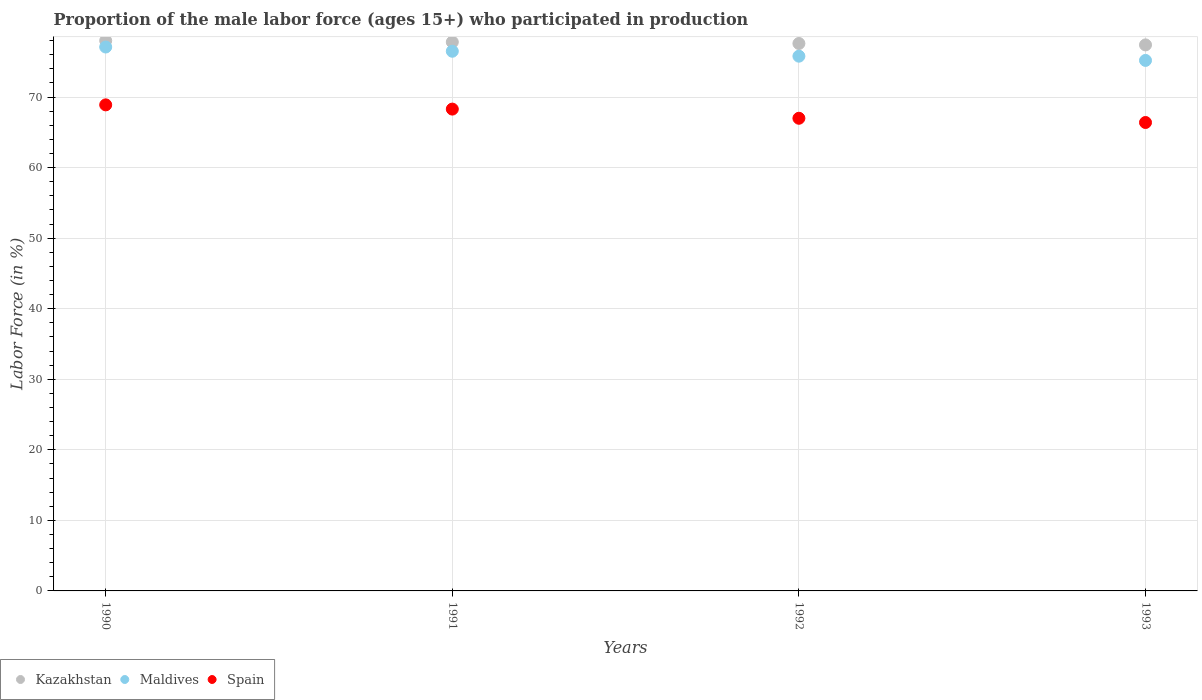Across all years, what is the minimum proportion of the male labor force who participated in production in Spain?
Offer a very short reply. 66.4. In which year was the proportion of the male labor force who participated in production in Spain maximum?
Keep it short and to the point. 1990. In which year was the proportion of the male labor force who participated in production in Spain minimum?
Ensure brevity in your answer.  1993. What is the total proportion of the male labor force who participated in production in Kazakhstan in the graph?
Make the answer very short. 310.8. What is the difference between the proportion of the male labor force who participated in production in Maldives in 1990 and that in 1992?
Keep it short and to the point. 1.3. What is the difference between the proportion of the male labor force who participated in production in Spain in 1991 and the proportion of the male labor force who participated in production in Maldives in 1990?
Offer a very short reply. -8.8. What is the average proportion of the male labor force who participated in production in Maldives per year?
Offer a terse response. 76.15. In the year 1992, what is the difference between the proportion of the male labor force who participated in production in Spain and proportion of the male labor force who participated in production in Kazakhstan?
Your response must be concise. -10.6. In how many years, is the proportion of the male labor force who participated in production in Spain greater than 38 %?
Your response must be concise. 4. What is the ratio of the proportion of the male labor force who participated in production in Kazakhstan in 1990 to that in 1991?
Your answer should be compact. 1. Is the proportion of the male labor force who participated in production in Spain in 1990 less than that in 1992?
Offer a very short reply. No. What is the difference between the highest and the second highest proportion of the male labor force who participated in production in Spain?
Your answer should be compact. 0.6. What is the difference between the highest and the lowest proportion of the male labor force who participated in production in Maldives?
Keep it short and to the point. 1.9. Is the sum of the proportion of the male labor force who participated in production in Kazakhstan in 1990 and 1993 greater than the maximum proportion of the male labor force who participated in production in Spain across all years?
Your answer should be very brief. Yes. Is it the case that in every year, the sum of the proportion of the male labor force who participated in production in Kazakhstan and proportion of the male labor force who participated in production in Maldives  is greater than the proportion of the male labor force who participated in production in Spain?
Provide a succinct answer. Yes. Does the proportion of the male labor force who participated in production in Maldives monotonically increase over the years?
Offer a terse response. No. Is the proportion of the male labor force who participated in production in Kazakhstan strictly greater than the proportion of the male labor force who participated in production in Spain over the years?
Your response must be concise. Yes. Is the proportion of the male labor force who participated in production in Spain strictly less than the proportion of the male labor force who participated in production in Kazakhstan over the years?
Offer a very short reply. Yes. How many dotlines are there?
Offer a terse response. 3. What is the difference between two consecutive major ticks on the Y-axis?
Your answer should be very brief. 10. Are the values on the major ticks of Y-axis written in scientific E-notation?
Provide a succinct answer. No. Does the graph contain any zero values?
Keep it short and to the point. No. Where does the legend appear in the graph?
Your answer should be very brief. Bottom left. What is the title of the graph?
Provide a succinct answer. Proportion of the male labor force (ages 15+) who participated in production. Does "Slovak Republic" appear as one of the legend labels in the graph?
Provide a short and direct response. No. What is the label or title of the X-axis?
Offer a terse response. Years. What is the label or title of the Y-axis?
Provide a short and direct response. Labor Force (in %). What is the Labor Force (in %) in Maldives in 1990?
Your response must be concise. 77.1. What is the Labor Force (in %) of Spain in 1990?
Your answer should be compact. 68.9. What is the Labor Force (in %) of Kazakhstan in 1991?
Provide a short and direct response. 77.8. What is the Labor Force (in %) of Maldives in 1991?
Keep it short and to the point. 76.5. What is the Labor Force (in %) of Spain in 1991?
Your answer should be very brief. 68.3. What is the Labor Force (in %) of Kazakhstan in 1992?
Your response must be concise. 77.6. What is the Labor Force (in %) of Maldives in 1992?
Your answer should be compact. 75.8. What is the Labor Force (in %) in Spain in 1992?
Offer a very short reply. 67. What is the Labor Force (in %) in Kazakhstan in 1993?
Your answer should be compact. 77.4. What is the Labor Force (in %) of Maldives in 1993?
Offer a terse response. 75.2. What is the Labor Force (in %) of Spain in 1993?
Offer a terse response. 66.4. Across all years, what is the maximum Labor Force (in %) in Maldives?
Give a very brief answer. 77.1. Across all years, what is the maximum Labor Force (in %) in Spain?
Offer a very short reply. 68.9. Across all years, what is the minimum Labor Force (in %) of Kazakhstan?
Keep it short and to the point. 77.4. Across all years, what is the minimum Labor Force (in %) of Maldives?
Keep it short and to the point. 75.2. Across all years, what is the minimum Labor Force (in %) of Spain?
Offer a terse response. 66.4. What is the total Labor Force (in %) in Kazakhstan in the graph?
Keep it short and to the point. 310.8. What is the total Labor Force (in %) of Maldives in the graph?
Your answer should be very brief. 304.6. What is the total Labor Force (in %) in Spain in the graph?
Your response must be concise. 270.6. What is the difference between the Labor Force (in %) in Kazakhstan in 1990 and that in 1991?
Make the answer very short. 0.2. What is the difference between the Labor Force (in %) of Maldives in 1990 and that in 1991?
Offer a terse response. 0.6. What is the difference between the Labor Force (in %) of Maldives in 1990 and that in 1992?
Provide a succinct answer. 1.3. What is the difference between the Labor Force (in %) in Spain in 1990 and that in 1992?
Keep it short and to the point. 1.9. What is the difference between the Labor Force (in %) in Kazakhstan in 1990 and that in 1993?
Your answer should be very brief. 0.6. What is the difference between the Labor Force (in %) in Kazakhstan in 1991 and that in 1992?
Your answer should be compact. 0.2. What is the difference between the Labor Force (in %) of Maldives in 1991 and that in 1992?
Give a very brief answer. 0.7. What is the difference between the Labor Force (in %) in Maldives in 1991 and that in 1993?
Your response must be concise. 1.3. What is the difference between the Labor Force (in %) in Spain in 1991 and that in 1993?
Provide a short and direct response. 1.9. What is the difference between the Labor Force (in %) of Spain in 1992 and that in 1993?
Give a very brief answer. 0.6. What is the difference between the Labor Force (in %) of Kazakhstan in 1990 and the Labor Force (in %) of Maldives in 1992?
Offer a terse response. 2.2. What is the difference between the Labor Force (in %) of Kazakhstan in 1991 and the Labor Force (in %) of Maldives in 1992?
Offer a very short reply. 2. What is the difference between the Labor Force (in %) of Kazakhstan in 1991 and the Labor Force (in %) of Spain in 1992?
Ensure brevity in your answer.  10.8. What is the difference between the Labor Force (in %) of Maldives in 1992 and the Labor Force (in %) of Spain in 1993?
Give a very brief answer. 9.4. What is the average Labor Force (in %) of Kazakhstan per year?
Offer a very short reply. 77.7. What is the average Labor Force (in %) in Maldives per year?
Provide a short and direct response. 76.15. What is the average Labor Force (in %) of Spain per year?
Give a very brief answer. 67.65. In the year 1990, what is the difference between the Labor Force (in %) in Kazakhstan and Labor Force (in %) in Maldives?
Offer a very short reply. 0.9. In the year 1990, what is the difference between the Labor Force (in %) of Kazakhstan and Labor Force (in %) of Spain?
Offer a terse response. 9.1. In the year 1990, what is the difference between the Labor Force (in %) of Maldives and Labor Force (in %) of Spain?
Make the answer very short. 8.2. In the year 1991, what is the difference between the Labor Force (in %) in Maldives and Labor Force (in %) in Spain?
Your response must be concise. 8.2. In the year 1992, what is the difference between the Labor Force (in %) in Kazakhstan and Labor Force (in %) in Maldives?
Ensure brevity in your answer.  1.8. In the year 1992, what is the difference between the Labor Force (in %) of Kazakhstan and Labor Force (in %) of Spain?
Your answer should be compact. 10.6. In the year 1992, what is the difference between the Labor Force (in %) in Maldives and Labor Force (in %) in Spain?
Make the answer very short. 8.8. In the year 1993, what is the difference between the Labor Force (in %) in Kazakhstan and Labor Force (in %) in Maldives?
Give a very brief answer. 2.2. In the year 1993, what is the difference between the Labor Force (in %) of Maldives and Labor Force (in %) of Spain?
Ensure brevity in your answer.  8.8. What is the ratio of the Labor Force (in %) in Spain in 1990 to that in 1991?
Your answer should be compact. 1.01. What is the ratio of the Labor Force (in %) of Kazakhstan in 1990 to that in 1992?
Make the answer very short. 1.01. What is the ratio of the Labor Force (in %) of Maldives in 1990 to that in 1992?
Offer a very short reply. 1.02. What is the ratio of the Labor Force (in %) in Spain in 1990 to that in 1992?
Provide a succinct answer. 1.03. What is the ratio of the Labor Force (in %) in Kazakhstan in 1990 to that in 1993?
Provide a short and direct response. 1.01. What is the ratio of the Labor Force (in %) of Maldives in 1990 to that in 1993?
Make the answer very short. 1.03. What is the ratio of the Labor Force (in %) of Spain in 1990 to that in 1993?
Your answer should be compact. 1.04. What is the ratio of the Labor Force (in %) in Kazakhstan in 1991 to that in 1992?
Provide a succinct answer. 1. What is the ratio of the Labor Force (in %) in Maldives in 1991 to that in 1992?
Your response must be concise. 1.01. What is the ratio of the Labor Force (in %) of Spain in 1991 to that in 1992?
Offer a very short reply. 1.02. What is the ratio of the Labor Force (in %) in Kazakhstan in 1991 to that in 1993?
Your response must be concise. 1.01. What is the ratio of the Labor Force (in %) in Maldives in 1991 to that in 1993?
Keep it short and to the point. 1.02. What is the ratio of the Labor Force (in %) of Spain in 1991 to that in 1993?
Provide a succinct answer. 1.03. What is the ratio of the Labor Force (in %) in Maldives in 1992 to that in 1993?
Make the answer very short. 1.01. What is the difference between the highest and the second highest Labor Force (in %) of Maldives?
Provide a succinct answer. 0.6. What is the difference between the highest and the second highest Labor Force (in %) of Spain?
Make the answer very short. 0.6. What is the difference between the highest and the lowest Labor Force (in %) in Kazakhstan?
Ensure brevity in your answer.  0.6. What is the difference between the highest and the lowest Labor Force (in %) of Spain?
Make the answer very short. 2.5. 